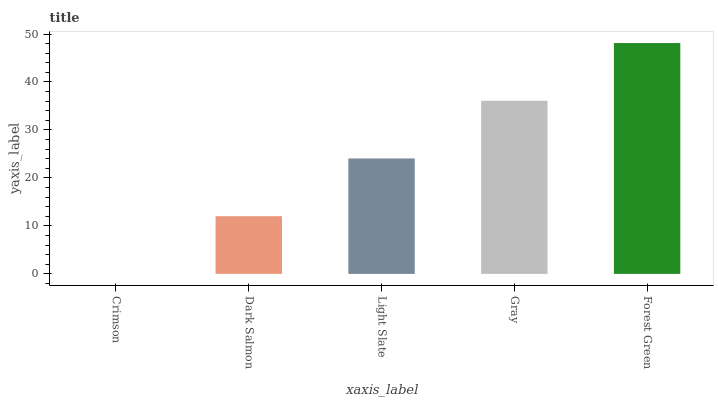Is Dark Salmon the minimum?
Answer yes or no. No. Is Dark Salmon the maximum?
Answer yes or no. No. Is Dark Salmon greater than Crimson?
Answer yes or no. Yes. Is Crimson less than Dark Salmon?
Answer yes or no. Yes. Is Crimson greater than Dark Salmon?
Answer yes or no. No. Is Dark Salmon less than Crimson?
Answer yes or no. No. Is Light Slate the high median?
Answer yes or no. Yes. Is Light Slate the low median?
Answer yes or no. Yes. Is Gray the high median?
Answer yes or no. No. Is Crimson the low median?
Answer yes or no. No. 